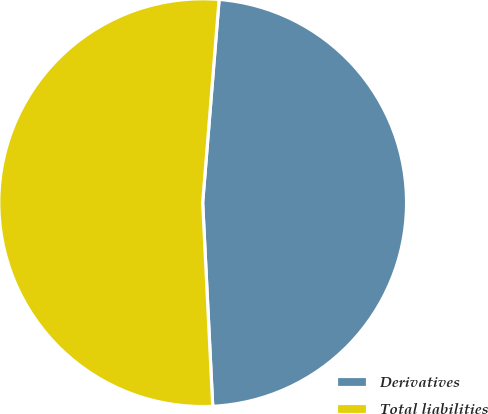Convert chart to OTSL. <chart><loc_0><loc_0><loc_500><loc_500><pie_chart><fcel>Derivatives<fcel>Total liabilities<nl><fcel>47.93%<fcel>52.07%<nl></chart> 